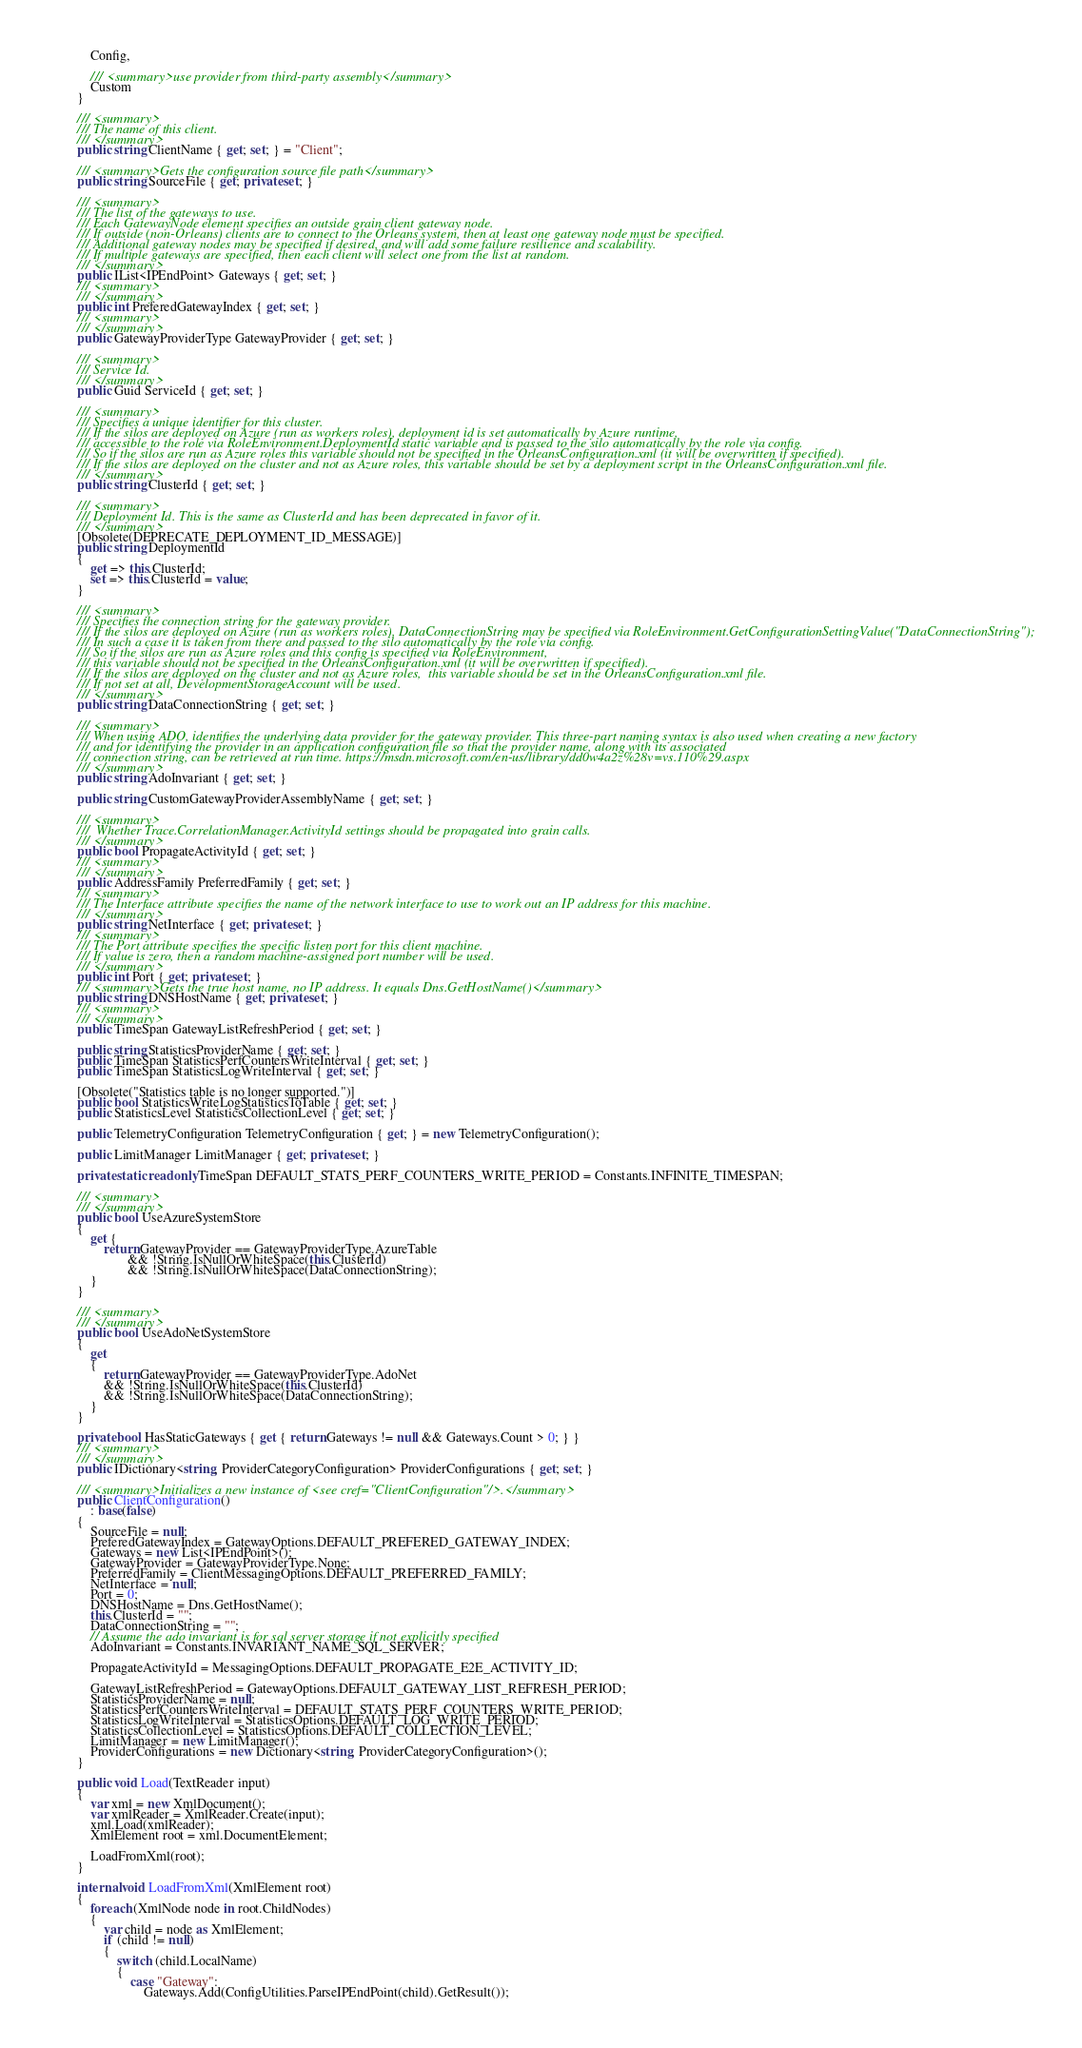Convert code to text. <code><loc_0><loc_0><loc_500><loc_500><_C#_>            Config,

            /// <summary>use provider from third-party assembly</summary>
            Custom
        }

        /// <summary>
        /// The name of this client.
        /// </summary>
        public string ClientName { get; set; } = "Client";

        /// <summary>Gets the configuration source file path</summary>
        public string SourceFile { get; private set; }

        /// <summary>
        /// The list of the gateways to use.
        /// Each GatewayNode element specifies an outside grain client gateway node.
        /// If outside (non-Orleans) clients are to connect to the Orleans system, then at least one gateway node must be specified.
        /// Additional gateway nodes may be specified if desired, and will add some failure resilience and scalability.
        /// If multiple gateways are specified, then each client will select one from the list at random.
        /// </summary>
        public IList<IPEndPoint> Gateways { get; set; }
        /// <summary>
        /// </summary>
        public int PreferedGatewayIndex { get; set; }
        /// <summary>
        /// </summary>
        public GatewayProviderType GatewayProvider { get; set; }

        /// <summary>
        /// Service Id.
        /// </summary>
        public Guid ServiceId { get; set; }

        /// <summary>
        /// Specifies a unique identifier for this cluster.
        /// If the silos are deployed on Azure (run as workers roles), deployment id is set automatically by Azure runtime, 
        /// accessible to the role via RoleEnvironment.DeploymentId static variable and is passed to the silo automatically by the role via config. 
        /// So if the silos are run as Azure roles this variable should not be specified in the OrleansConfiguration.xml (it will be overwritten if specified).
        /// If the silos are deployed on the cluster and not as Azure roles, this variable should be set by a deployment script in the OrleansConfiguration.xml file.
        /// </summary>
        public string ClusterId { get; set; }

        /// <summary>
        /// Deployment Id. This is the same as ClusterId and has been deprecated in favor of it.
        /// </summary>
        [Obsolete(DEPRECATE_DEPLOYMENT_ID_MESSAGE)]
        public string DeploymentId
        {
            get => this.ClusterId;
            set => this.ClusterId = value;
        }

        /// <summary>
        /// Specifies the connection string for the gateway provider.
        /// If the silos are deployed on Azure (run as workers roles), DataConnectionString may be specified via RoleEnvironment.GetConfigurationSettingValue("DataConnectionString");
        /// In such a case it is taken from there and passed to the silo automatically by the role via config.
        /// So if the silos are run as Azure roles and this config is specified via RoleEnvironment, 
        /// this variable should not be specified in the OrleansConfiguration.xml (it will be overwritten if specified).
        /// If the silos are deployed on the cluster and not as Azure roles,  this variable should be set in the OrleansConfiguration.xml file.
        /// If not set at all, DevelopmentStorageAccount will be used.
        /// </summary>
        public string DataConnectionString { get; set; }

        /// <summary>
        /// When using ADO, identifies the underlying data provider for the gateway provider. This three-part naming syntax is also used when creating a new factory 
        /// and for identifying the provider in an application configuration file so that the provider name, along with its associated 
        /// connection string, can be retrieved at run time. https://msdn.microsoft.com/en-us/library/dd0w4a2z%28v=vs.110%29.aspx
        /// </summary>
        public string AdoInvariant { get; set; }

        public string CustomGatewayProviderAssemblyName { get; set; }

        /// <summary>
        ///  Whether Trace.CorrelationManager.ActivityId settings should be propagated into grain calls.
        /// </summary>
        public bool PropagateActivityId { get; set; }
        /// <summary>
        /// </summary>
        public AddressFamily PreferredFamily { get; set; }
        /// <summary>
        /// The Interface attribute specifies the name of the network interface to use to work out an IP address for this machine.
        /// </summary>
        public string NetInterface { get; private set; }
        /// <summary>
        /// The Port attribute specifies the specific listen port for this client machine.
        /// If value is zero, then a random machine-assigned port number will be used.
        /// </summary>
        public int Port { get; private set; }
        /// <summary>Gets the true host name, no IP address. It equals Dns.GetHostName()</summary>
        public string DNSHostName { get; private set; }
        /// <summary>
        /// </summary>
        public TimeSpan GatewayListRefreshPeriod { get; set; }

        public string StatisticsProviderName { get; set; }
        public TimeSpan StatisticsPerfCountersWriteInterval { get; set; }
        public TimeSpan StatisticsLogWriteInterval { get; set; }

        [Obsolete("Statistics table is no longer supported.")]
        public bool StatisticsWriteLogStatisticsToTable { get; set; }
        public StatisticsLevel StatisticsCollectionLevel { get; set; }

        public TelemetryConfiguration TelemetryConfiguration { get; } = new TelemetryConfiguration();

        public LimitManager LimitManager { get; private set; }
        
        private static readonly TimeSpan DEFAULT_STATS_PERF_COUNTERS_WRITE_PERIOD = Constants.INFINITE_TIMESPAN;

        /// <summary>
        /// </summary>
        public bool UseAzureSystemStore 
        { 
            get { 
                return GatewayProvider == GatewayProviderType.AzureTable 
                       && !String.IsNullOrWhiteSpace(this.ClusterId) 
                       && !String.IsNullOrWhiteSpace(DataConnectionString); 
            } 
        }

        /// <summary>
        /// </summary>
        public bool UseAdoNetSystemStore
        {
            get
            {
                return GatewayProvider == GatewayProviderType.AdoNet
                && !String.IsNullOrWhiteSpace(this.ClusterId)
                && !String.IsNullOrWhiteSpace(DataConnectionString);
            }
        }

        private bool HasStaticGateways { get { return Gateways != null && Gateways.Count > 0; } }
        /// <summary>
        /// </summary>
        public IDictionary<string, ProviderCategoryConfiguration> ProviderConfigurations { get; set; }

        /// <summary>Initializes a new instance of <see cref="ClientConfiguration"/>.</summary>
        public ClientConfiguration()
            : base(false)
        {
            SourceFile = null;
            PreferedGatewayIndex = GatewayOptions.DEFAULT_PREFERED_GATEWAY_INDEX;
            Gateways = new List<IPEndPoint>();
            GatewayProvider = GatewayProviderType.None;
            PreferredFamily = ClientMessagingOptions.DEFAULT_PREFERRED_FAMILY;
            NetInterface = null;
            Port = 0;
            DNSHostName = Dns.GetHostName();
            this.ClusterId = "";
            DataConnectionString = "";
            // Assume the ado invariant is for sql server storage if not explicitly specified
            AdoInvariant = Constants.INVARIANT_NAME_SQL_SERVER;
            
            PropagateActivityId = MessagingOptions.DEFAULT_PROPAGATE_E2E_ACTIVITY_ID;

            GatewayListRefreshPeriod = GatewayOptions.DEFAULT_GATEWAY_LIST_REFRESH_PERIOD;
            StatisticsProviderName = null;
            StatisticsPerfCountersWriteInterval = DEFAULT_STATS_PERF_COUNTERS_WRITE_PERIOD;
            StatisticsLogWriteInterval = StatisticsOptions.DEFAULT_LOG_WRITE_PERIOD;
            StatisticsCollectionLevel = StatisticsOptions.DEFAULT_COLLECTION_LEVEL;
            LimitManager = new LimitManager();
            ProviderConfigurations = new Dictionary<string, ProviderCategoryConfiguration>();
        }

        public void Load(TextReader input)
        {
            var xml = new XmlDocument();
            var xmlReader = XmlReader.Create(input);
            xml.Load(xmlReader);
            XmlElement root = xml.DocumentElement;

            LoadFromXml(root);
        }

        internal void LoadFromXml(XmlElement root)
        {
            foreach (XmlNode node in root.ChildNodes)
            {
                var child = node as XmlElement;
                if (child != null)
                {
                    switch (child.LocalName)
                    {
                        case "Gateway":
                            Gateways.Add(ConfigUtilities.ParseIPEndPoint(child).GetResult());</code> 